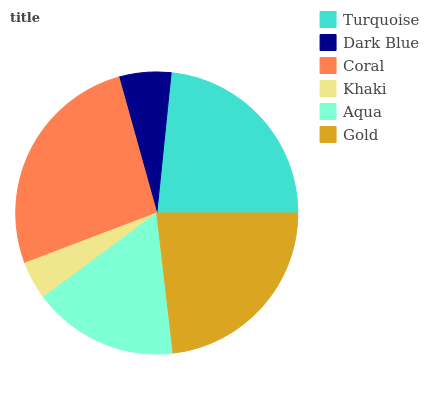Is Khaki the minimum?
Answer yes or no. Yes. Is Coral the maximum?
Answer yes or no. Yes. Is Dark Blue the minimum?
Answer yes or no. No. Is Dark Blue the maximum?
Answer yes or no. No. Is Turquoise greater than Dark Blue?
Answer yes or no. Yes. Is Dark Blue less than Turquoise?
Answer yes or no. Yes. Is Dark Blue greater than Turquoise?
Answer yes or no. No. Is Turquoise less than Dark Blue?
Answer yes or no. No. Is Gold the high median?
Answer yes or no. Yes. Is Aqua the low median?
Answer yes or no. Yes. Is Aqua the high median?
Answer yes or no. No. Is Turquoise the low median?
Answer yes or no. No. 